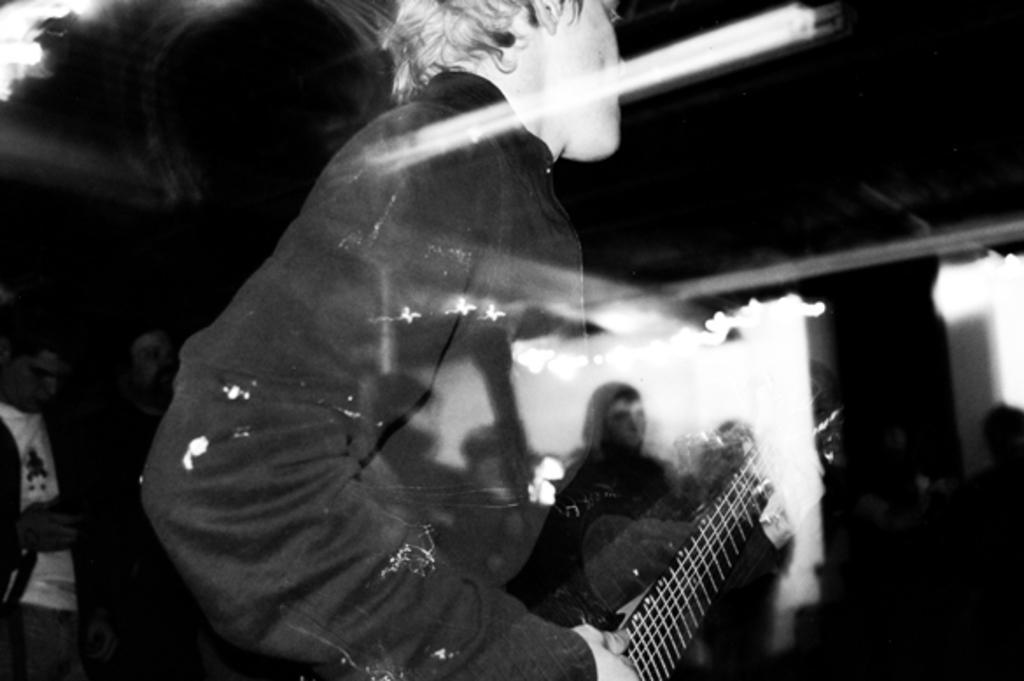In one or two sentences, can you explain what this image depicts? In this image I can see a person. In the background the image is blur. 